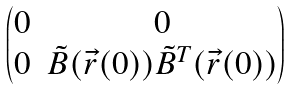Convert formula to latex. <formula><loc_0><loc_0><loc_500><loc_500>\begin{pmatrix} 0 & 0 \\ 0 & \tilde { B } ( \vec { r } ( 0 ) ) \tilde { B } ^ { T } ( \vec { r } ( 0 ) ) \end{pmatrix}</formula> 